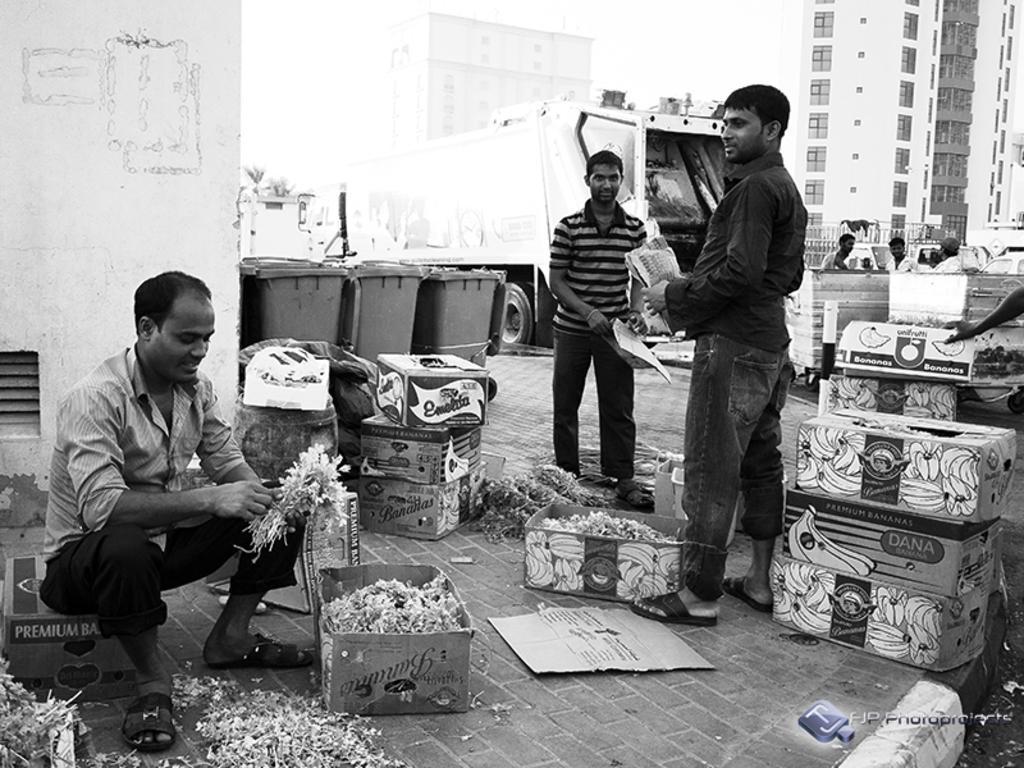In one or two sentences, can you explain what this image depicts? In the bottom left corner of the image a person is sitting and holding some papers. Behind him there is a wall. In the middle of the image two persons are standing and holding some papers and there are some boxes. Behind the boxes there is a vehicle and dustbins and few people are standing. At the top of the image there are some buildings. 